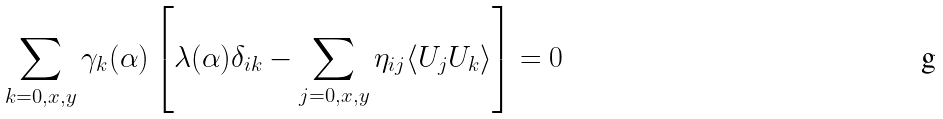Convert formula to latex. <formula><loc_0><loc_0><loc_500><loc_500>\sum _ { k = 0 , x , y } \gamma _ { k } ( \alpha ) \left [ \lambda ( \alpha ) \delta _ { i k } - \sum _ { j = 0 , x , y } \eta _ { i j } \langle U _ { j } U _ { k } \rangle \right ] = 0</formula> 